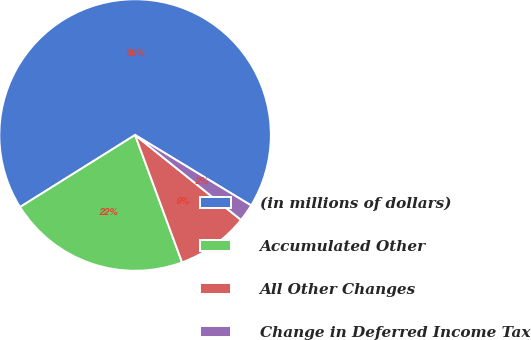Convert chart to OTSL. <chart><loc_0><loc_0><loc_500><loc_500><pie_chart><fcel>(in millions of dollars)<fcel>Accumulated Other<fcel>All Other Changes<fcel>Change in Deferred Income Tax<nl><fcel>67.58%<fcel>21.72%<fcel>8.62%<fcel>2.07%<nl></chart> 